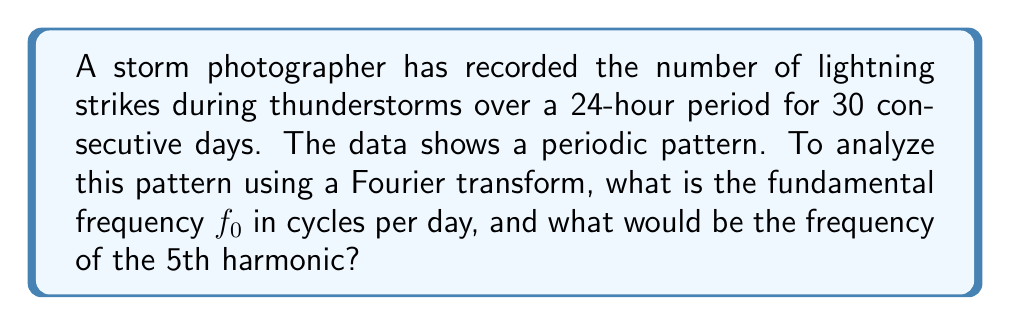Solve this math problem. To solve this problem, we need to follow these steps:

1) First, we need to determine the fundamental frequency $f_0$. The fundamental frequency is the reciprocal of the period of the data.

   Period = 30 days
   $f_0 = \frac{1}{\text{Period}} = \frac{1}{30} \text{ cycles/day}$

2) The frequency of the nth harmonic is given by $n \cdot f_0$, where n is a positive integer.

3) For the 5th harmonic, n = 5. So:

   $f_5 = 5 \cdot f_0 = 5 \cdot \frac{1}{30} = \frac{1}{6} \text{ cycles/day}$

In the context of Fourier transforms, these frequencies would correspond to specific components in the frequency domain representation of the storm data. The fundamental frequency represents the main periodic component, while the harmonics represent higher frequency components that contribute to the overall pattern of storm occurrences.

For a marketing manager, understanding these frequencies could be useful in predicting and promoting upcoming periods of increased storm activity, which could lead to more dramatic photography opportunities.
Answer: $f_0 = \frac{1}{30} \text{ cycles/day}$, $f_5 = \frac{1}{6} \text{ cycles/day}$ 